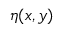<formula> <loc_0><loc_0><loc_500><loc_500>\eta ( x , y )</formula> 